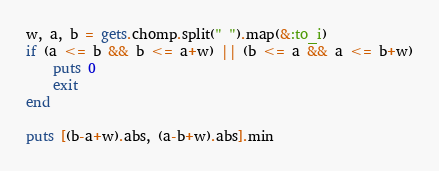<code> <loc_0><loc_0><loc_500><loc_500><_Ruby_>w, a, b = gets.chomp.split(" ").map(&:to_i)
if (a <= b && b <= a+w) || (b <= a && a <= b+w)
    puts 0
    exit
end

puts [(b-a+w).abs, (a-b+w).abs].min</code> 